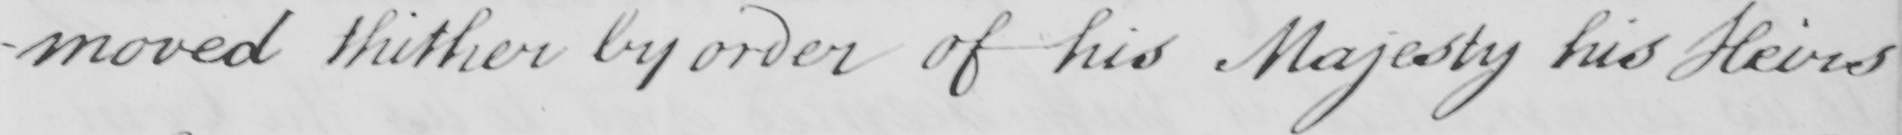Please transcribe the handwritten text in this image. -moved thither by order of his Majesty his Heirs 